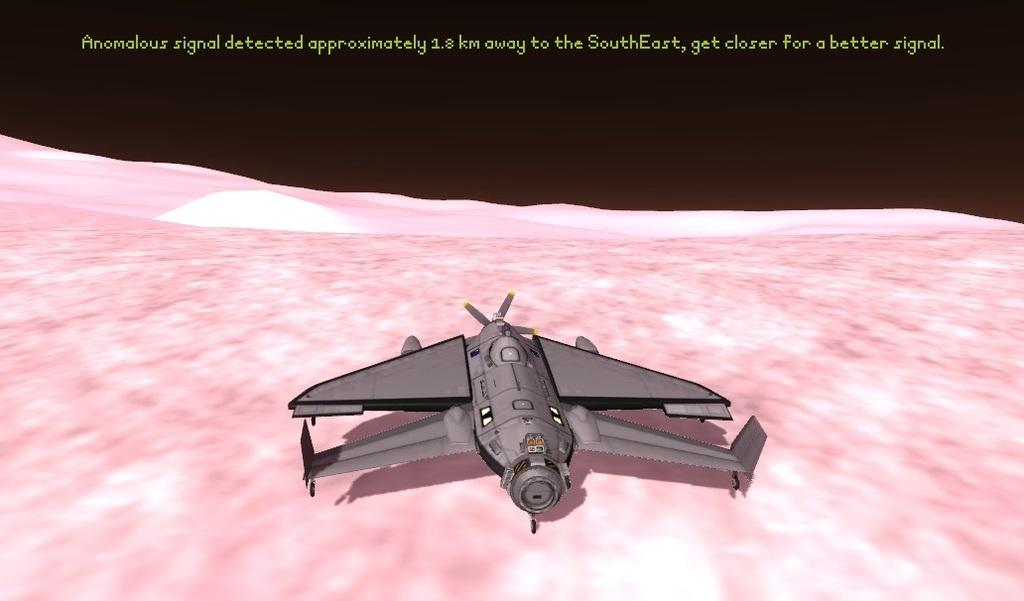What type of image is being described? The image is animated. What is the main object in the image? There is a rocket in the image. Where is the text located in the image? The text is at the top of the image. What type of butter is being used to turn the cow in the image? There is no butter, cow, or turning motion present in the image; it features an animated rocket and text at the top. 